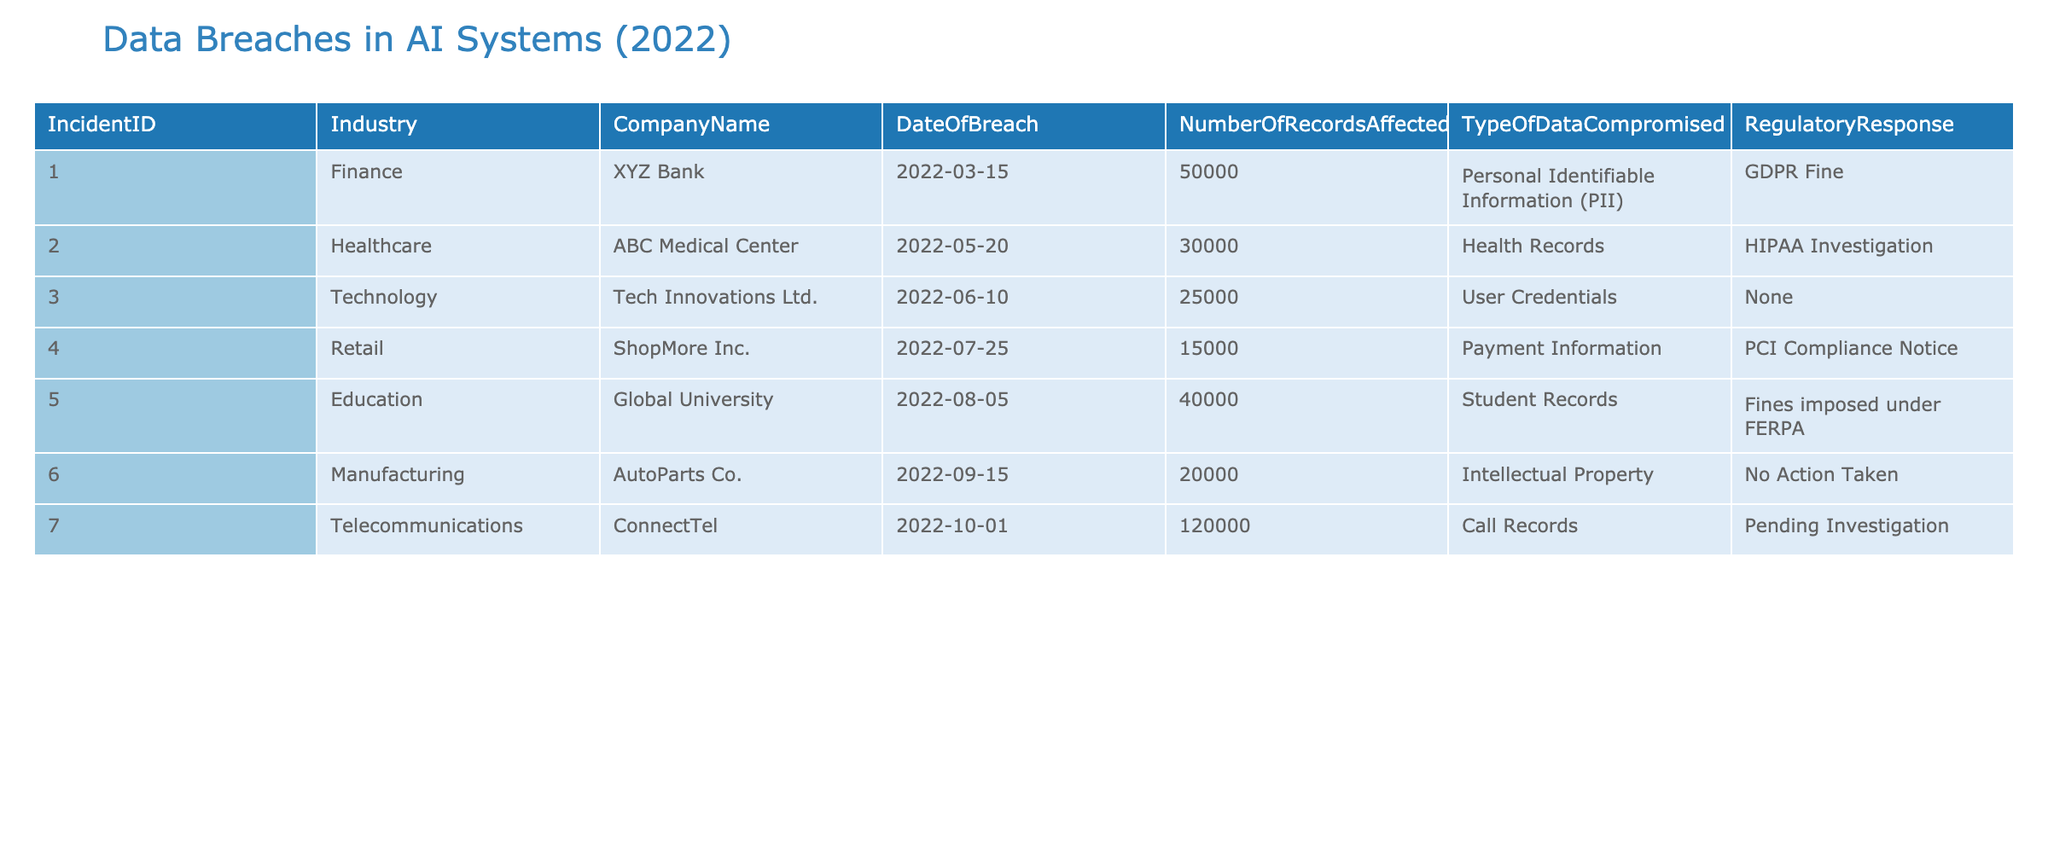What is the company with the highest number of records affected? By examining the "Number Of Records Affected" column, we see that "ConnectTel" has 120000 records, which is the largest compared to other companies listed.
Answer: ConnectTel How many incidents involved payment information? Looking at the "Type Of Data Compromised" column, only one incident with "Payment Information," from "ShopMore Inc.," is found when we review the data.
Answer: 1 What was the regulatory response for the incident that breached health records? The incident involving health records occurred at "ABC Medical Center," and the regulatory response listed is "HIPAA Investigation."
Answer: HIPAA Investigation Which industry had the least number of records affected in a data breach? By reviewing the "Number Of Records Affected" column, "ShopMore Inc." in the Retail industry had the least with 15000 records affected.
Answer: Retail Did "AutoParts Co." receive any regulatory action for their data breach? According to the "Regulatory Response" column, "AutoParts Co." did not receive any regulatory action as it states "No Action Taken."
Answer: No What is the total number of records affected across all incidents? We sum the "Number Of Records Affected" for all incidents: 50000 + 30000 + 25000 + 15000 + 40000 + 20000 + 120000 =  200000 records affected in total across all reported incidents.
Answer: 200000 Is there any incident reported in the technology sector that had a regulatory response? Reviewing both the "Industry" column and the "Regulatory Response" column, "Tech Innovations Ltd." did not have any regulatory response noted for their incident.
Answer: No What percentage of breaches involved personal identifiable information (PII)? There is one incident involving PII out of seven total incidents. To find the percentage, we can calculate (1/7)*100, which equals approximately 14.29%.
Answer: 14.29% 